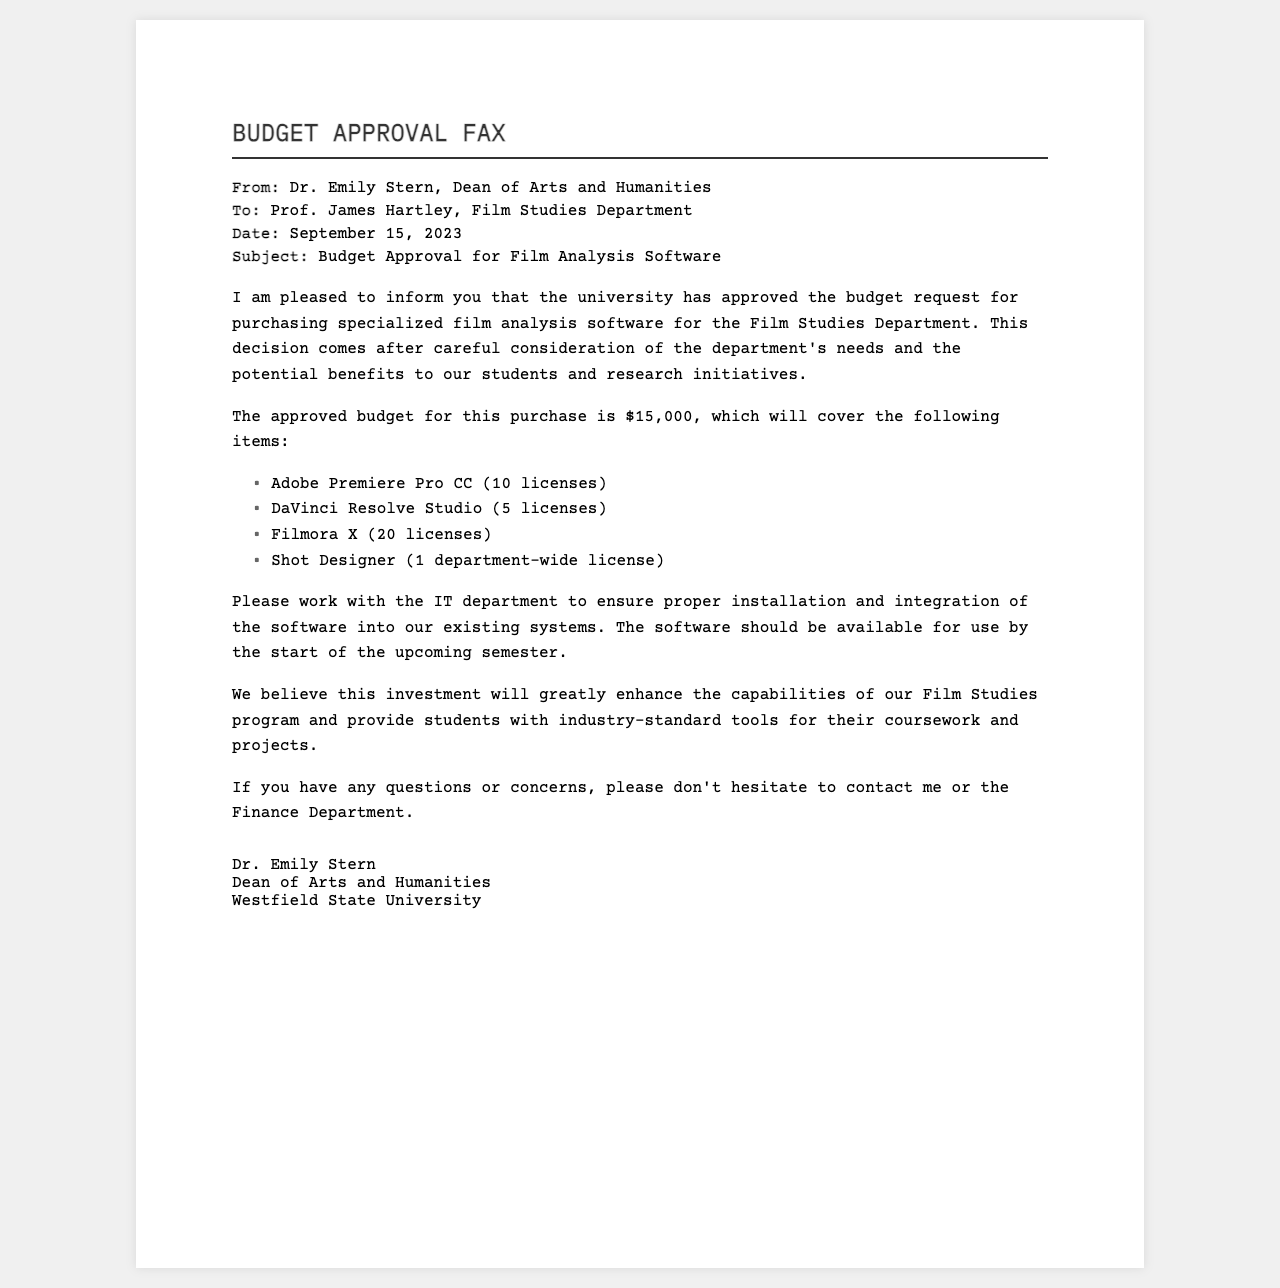what is the sender's name? The sender's name is specified at the top of the fax, identifying who it is from.
Answer: Dr. Emily Stern what is the date of the fax? The date can be found right below the recipient's details, indicating when the fax was sent.
Answer: September 15, 2023 how much is the approved budget? The document states the total amount allocated for the purchase of the software.
Answer: $15,000 how many licenses of Adobe Premiere Pro CC are approved? The number of licenses is listed in the details of the approved purchases.
Answer: 10 licenses what is one software included in the approved budget? Several software items are listed in the document; this question asks for any one of them.
Answer: Adobe Premiere Pro CC who should be contacted for questions or concerns? The document suggests who to reach out to regarding inquiries related to the budget or software integration.
Answer: Dr. Emily Stern or the Finance Department what is the expected availability of the software? The document mentions when the software should be operational for users in the department.
Answer: Start of the upcoming semester what is the title of the document? The title appears prominently at the top of the fax, indicating the main subject matter.
Answer: BUDGET APPROVAL FAX how many licenses of Filmora X are approved? The number of licenses is specified in the itemized list of approved software purchases.
Answer: 20 licenses 